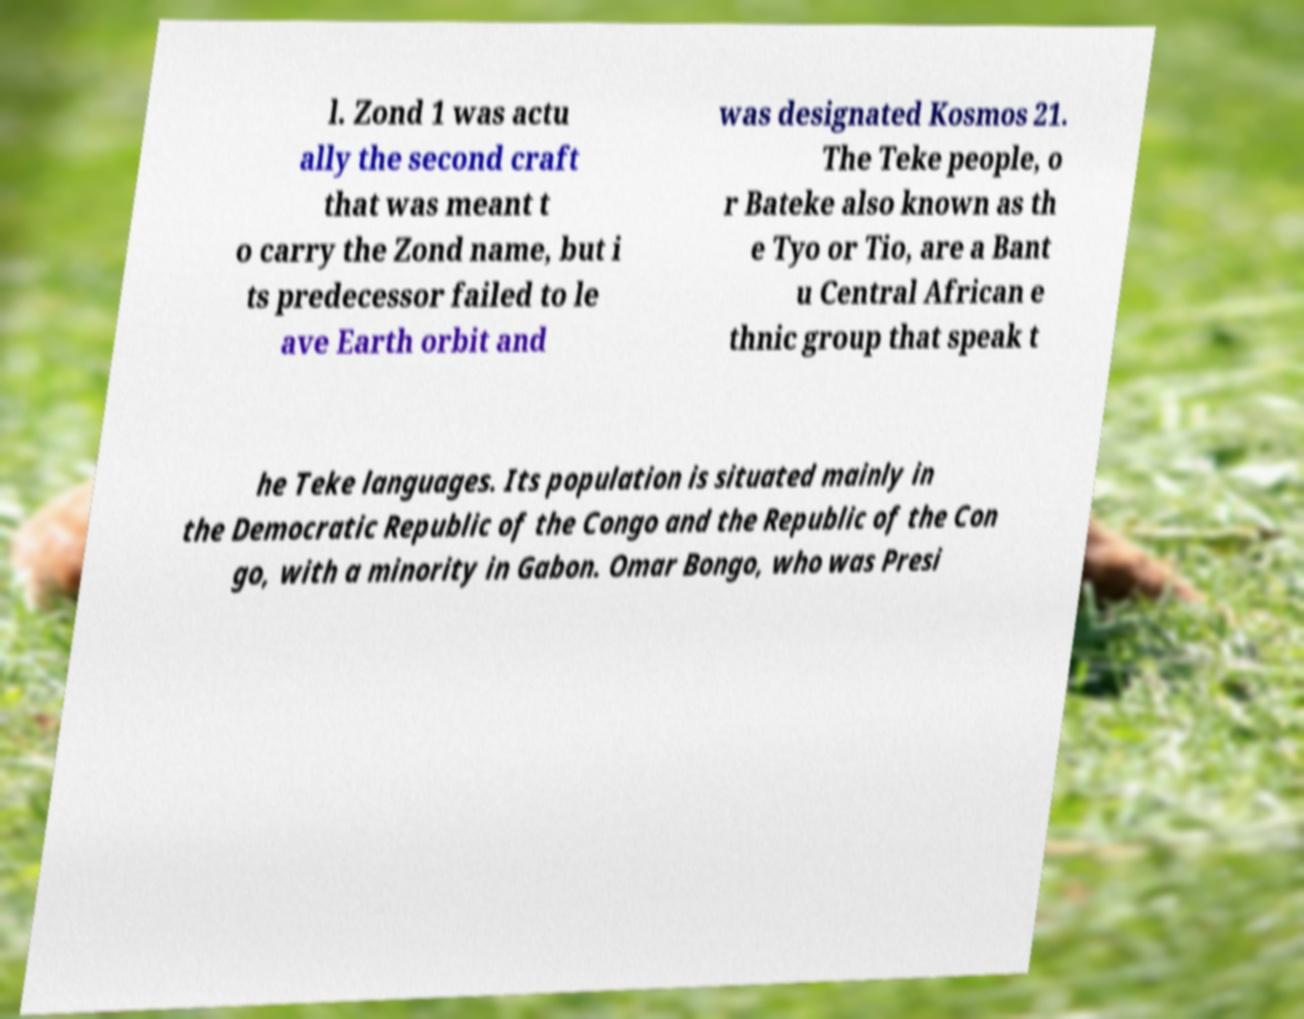For documentation purposes, I need the text within this image transcribed. Could you provide that? l. Zond 1 was actu ally the second craft that was meant t o carry the Zond name, but i ts predecessor failed to le ave Earth orbit and was designated Kosmos 21. The Teke people, o r Bateke also known as th e Tyo or Tio, are a Bant u Central African e thnic group that speak t he Teke languages. Its population is situated mainly in the Democratic Republic of the Congo and the Republic of the Con go, with a minority in Gabon. Omar Bongo, who was Presi 